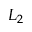Convert formula to latex. <formula><loc_0><loc_0><loc_500><loc_500>L _ { 2 }</formula> 